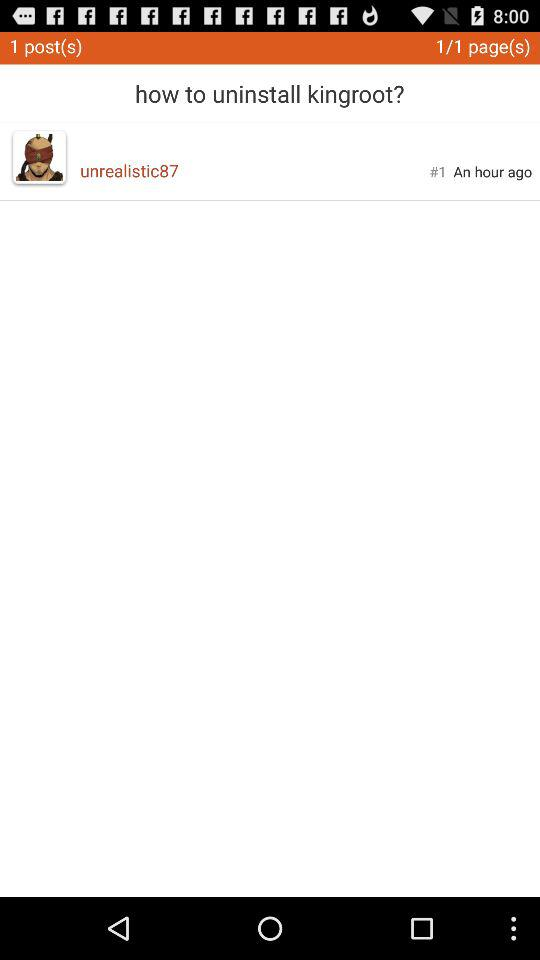How many pages in total are there? There is 1 page in total. 